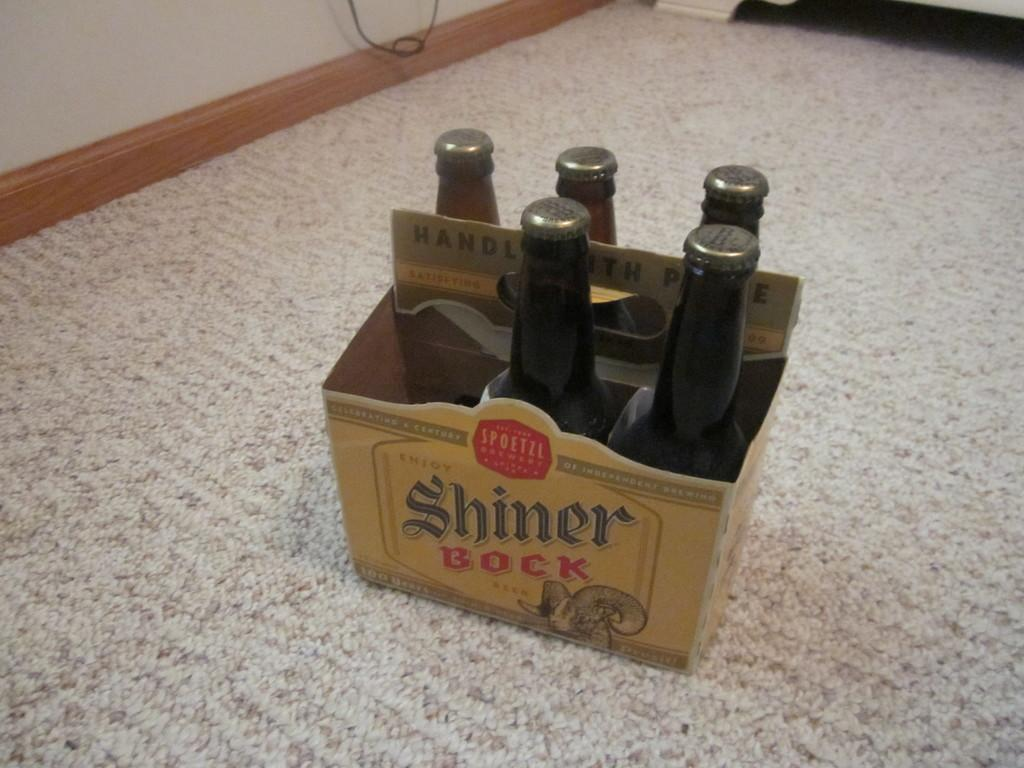Provide a one-sentence caption for the provided image. A six pack of Shiner Bock beer appears to have one bottle missing. 